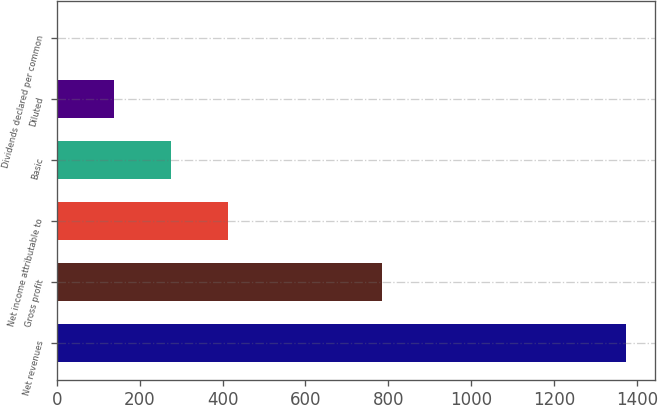<chart> <loc_0><loc_0><loc_500><loc_500><bar_chart><fcel>Net revenues<fcel>Gross profit<fcel>Net income attributable to<fcel>Basic<fcel>Diluted<fcel>Dividends declared per common<nl><fcel>1374.2<fcel>784.8<fcel>412.3<fcel>274.88<fcel>137.47<fcel>0.05<nl></chart> 